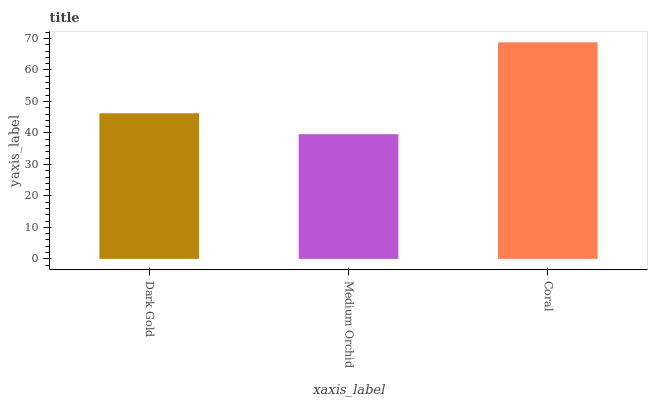Is Medium Orchid the minimum?
Answer yes or no. Yes. Is Coral the maximum?
Answer yes or no. Yes. Is Coral the minimum?
Answer yes or no. No. Is Medium Orchid the maximum?
Answer yes or no. No. Is Coral greater than Medium Orchid?
Answer yes or no. Yes. Is Medium Orchid less than Coral?
Answer yes or no. Yes. Is Medium Orchid greater than Coral?
Answer yes or no. No. Is Coral less than Medium Orchid?
Answer yes or no. No. Is Dark Gold the high median?
Answer yes or no. Yes. Is Dark Gold the low median?
Answer yes or no. Yes. Is Medium Orchid the high median?
Answer yes or no. No. Is Coral the low median?
Answer yes or no. No. 